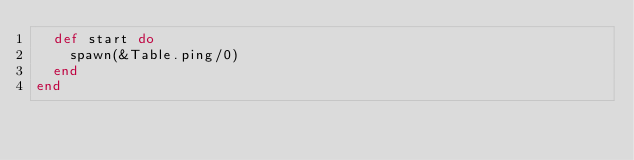<code> <loc_0><loc_0><loc_500><loc_500><_Elixir_>  def start do
    spawn(&Table.ping/0)
  end
end
</code> 